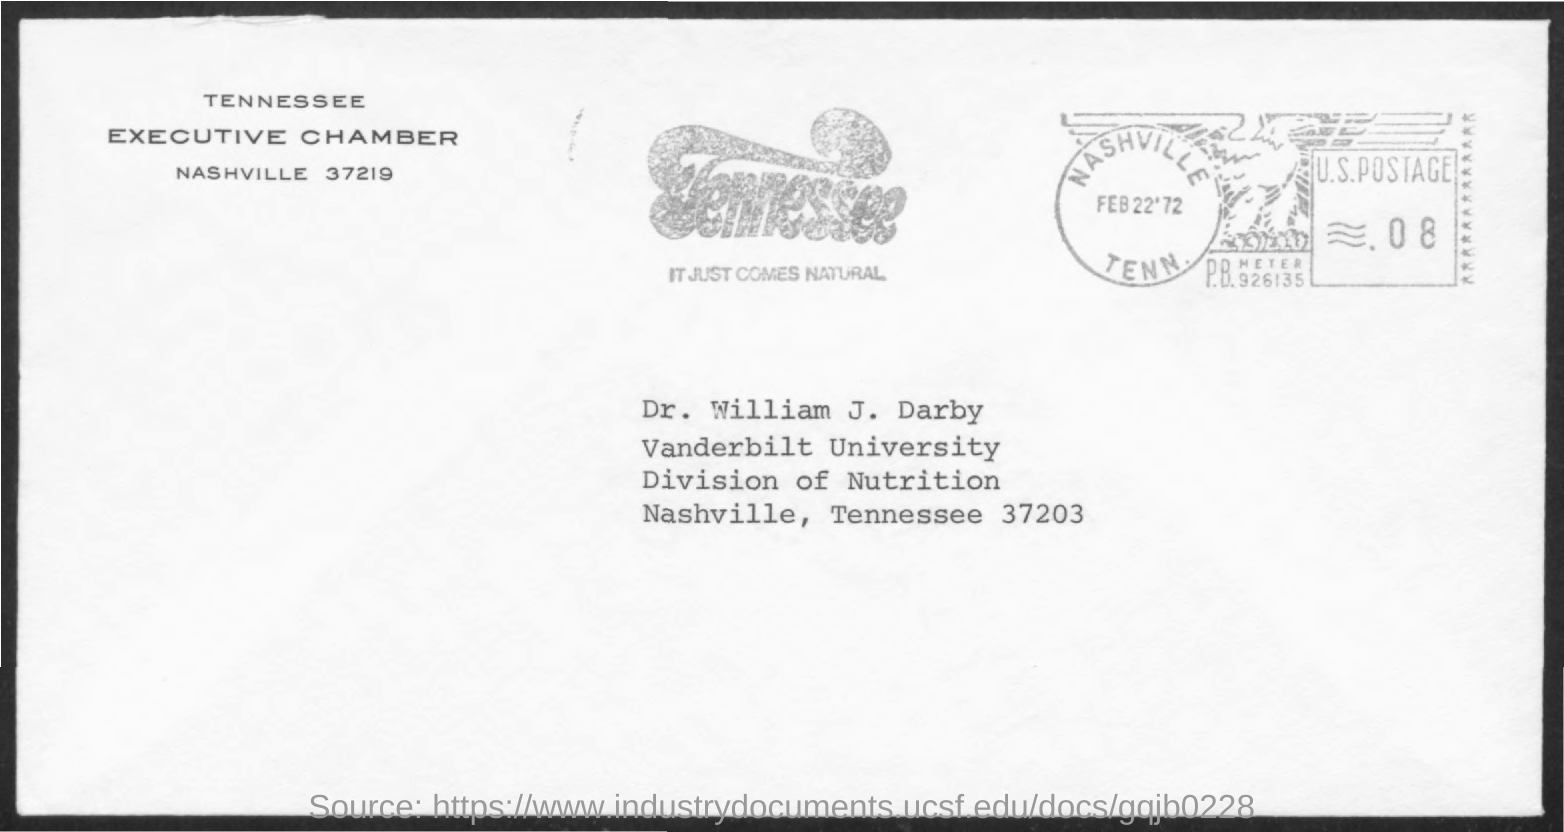Highlight a few significant elements in this photo. The letter, with the header "TENNESSEE EXECUTIVE CHAMBER," is unsigned, and its intended recipient is unknown. The letter is addressed to DR. WILLIAM J. DARBY. 